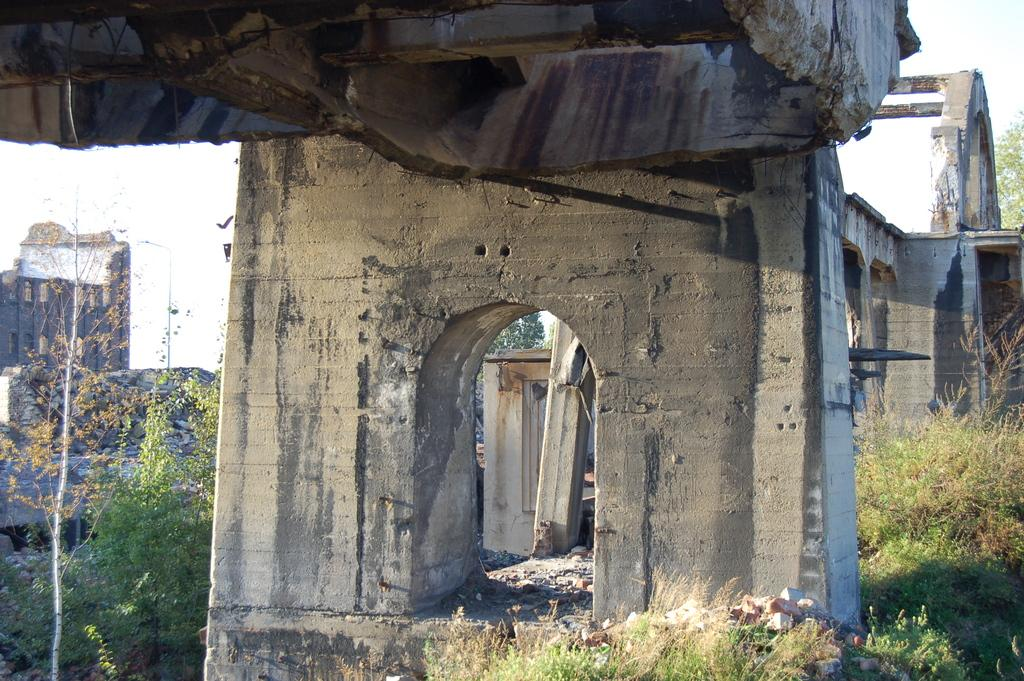What structure is the main subject of the image? There is a bridge in the image. What are the pillars used for in the image? The pillars support the bridge in the image. What type of vegetation can be seen in the image? There are green and brown trees in the image. What can be seen in the background of the image? There are buildings and trees in the background of the image, as well as the sky. What type of jail can be seen in the image? There is no jail present in the image; it features a bridge with pillars, trees, and buildings in the background. What committee is responsible for the maintenance of the bridge in the image? There is no information about a committee responsible for the maintenance of the bridge in the image. 